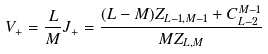Convert formula to latex. <formula><loc_0><loc_0><loc_500><loc_500>V _ { + } = \frac { L } { M } J _ { + } = \frac { ( L - M ) Z _ { L - 1 , M - 1 } + C _ { L - 2 } ^ { M - 1 } } { M Z _ { L , M } }</formula> 